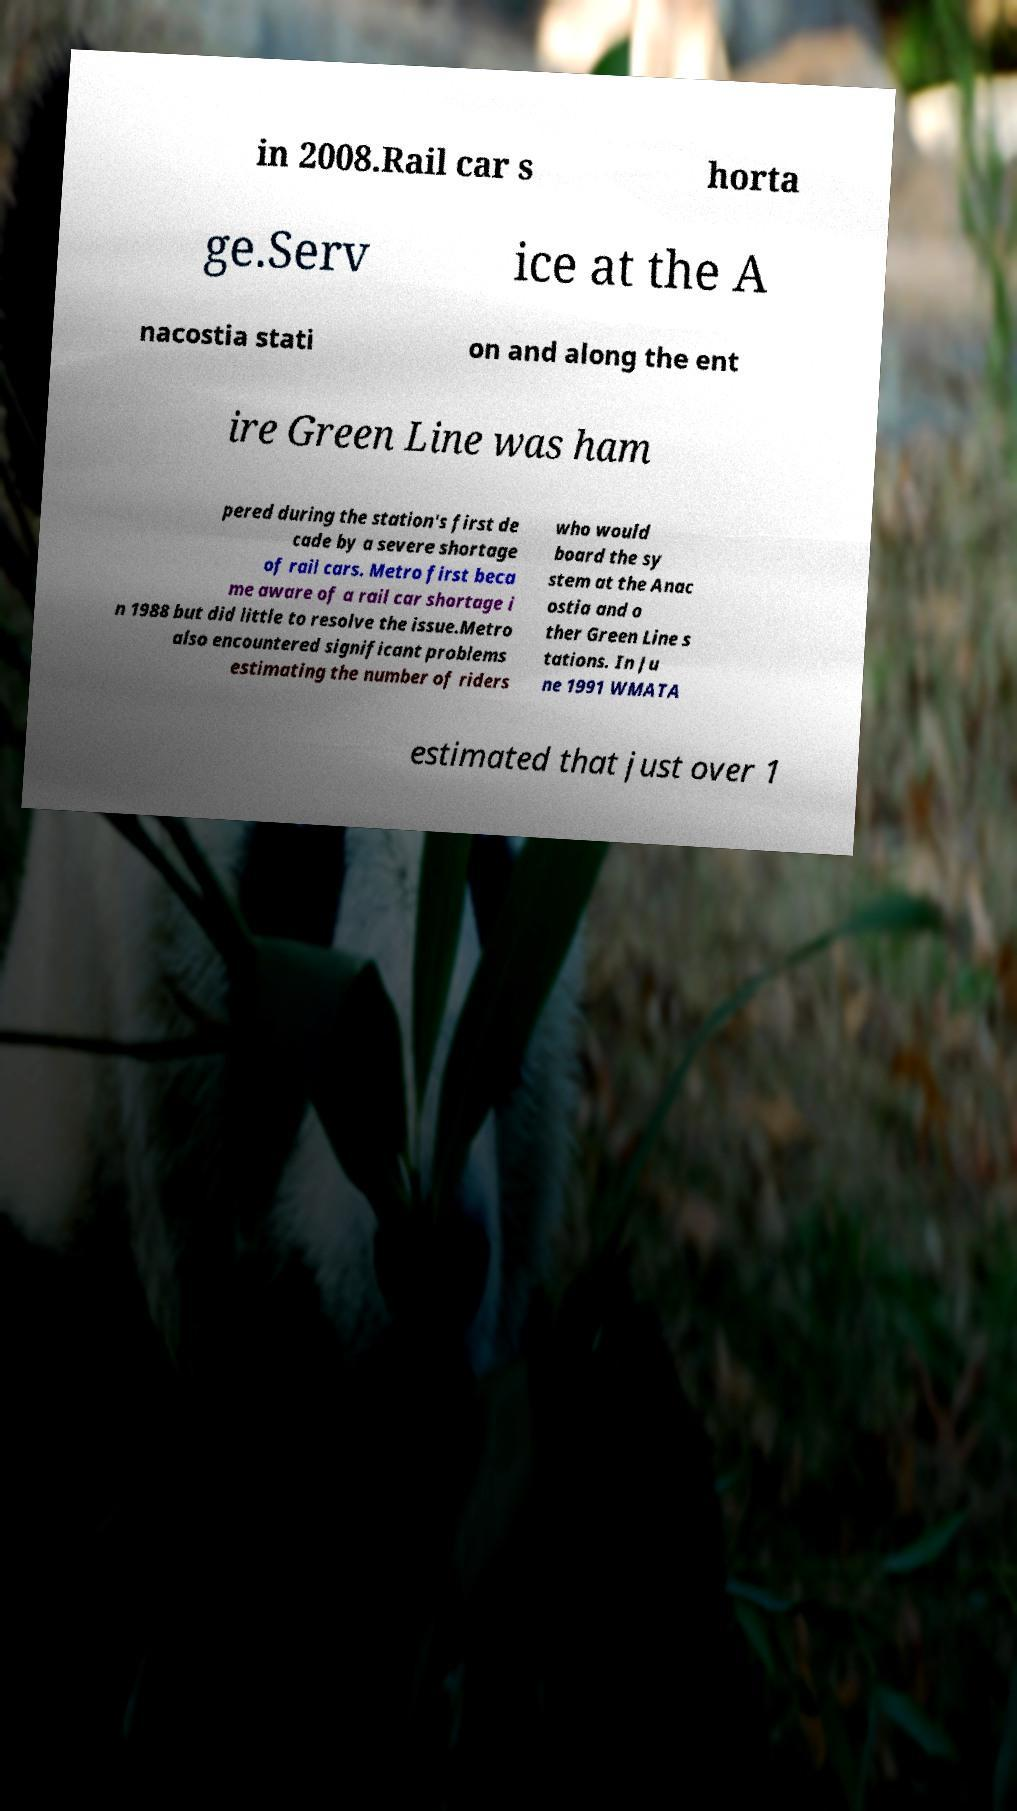I need the written content from this picture converted into text. Can you do that? in 2008.Rail car s horta ge.Serv ice at the A nacostia stati on and along the ent ire Green Line was ham pered during the station's first de cade by a severe shortage of rail cars. Metro first beca me aware of a rail car shortage i n 1988 but did little to resolve the issue.Metro also encountered significant problems estimating the number of riders who would board the sy stem at the Anac ostia and o ther Green Line s tations. In Ju ne 1991 WMATA estimated that just over 1 